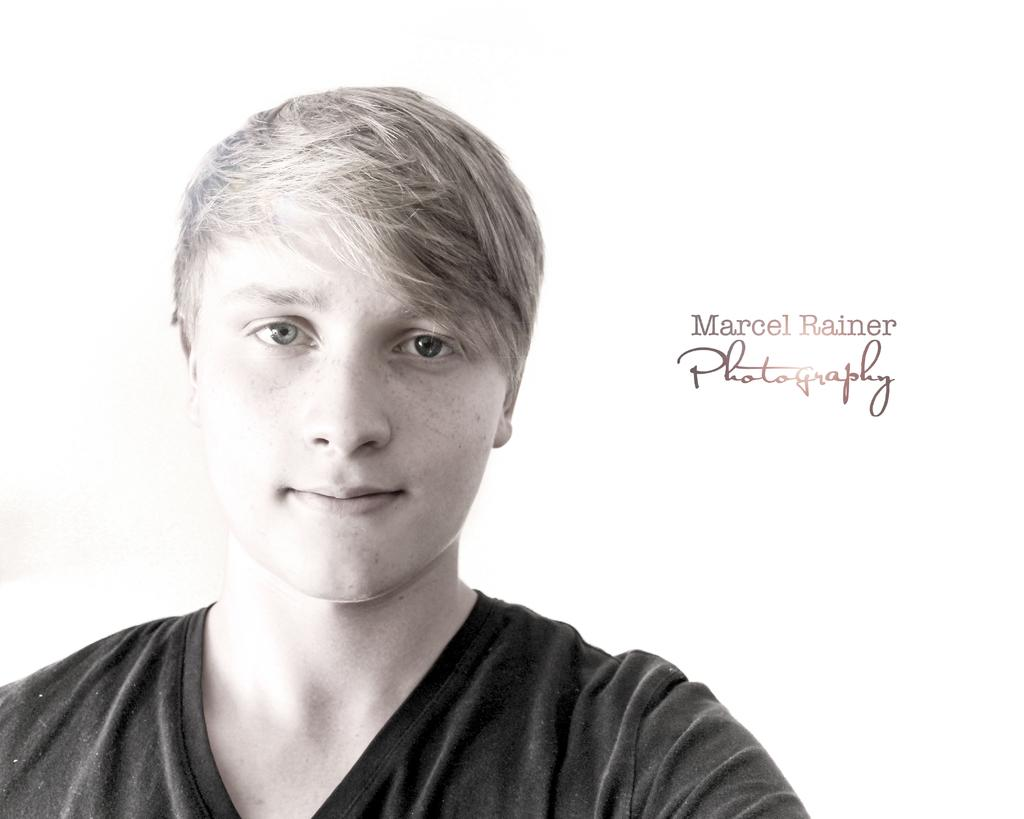What is the main subject of the image? There is a person in the image. What is the person wearing? The person is wearing a black T-shirt. Where is the text located in the image? The text is on the right side of the image. What is the color of the background in the image? The background of the image is white. How many toads can be seen in the image? There are no toads present in the image. What type of sand is visible in the image? There is no sand visible in the image. 